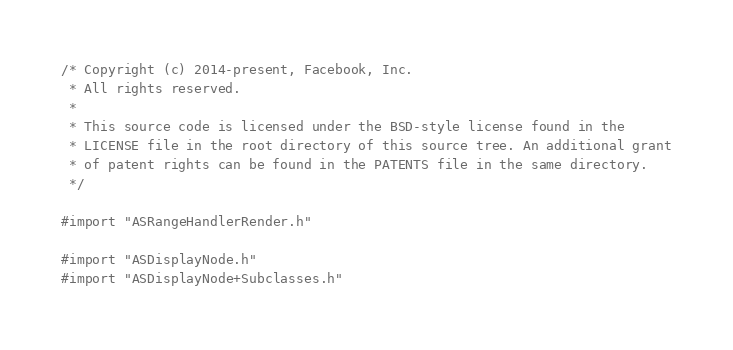Convert code to text. <code><loc_0><loc_0><loc_500><loc_500><_ObjectiveC_>/* Copyright (c) 2014-present, Facebook, Inc.
 * All rights reserved.
 *
 * This source code is licensed under the BSD-style license found in the
 * LICENSE file in the root directory of this source tree. An additional grant
 * of patent rights can be found in the PATENTS file in the same directory.
 */

#import "ASRangeHandlerRender.h"

#import "ASDisplayNode.h"
#import "ASDisplayNode+Subclasses.h"</code> 